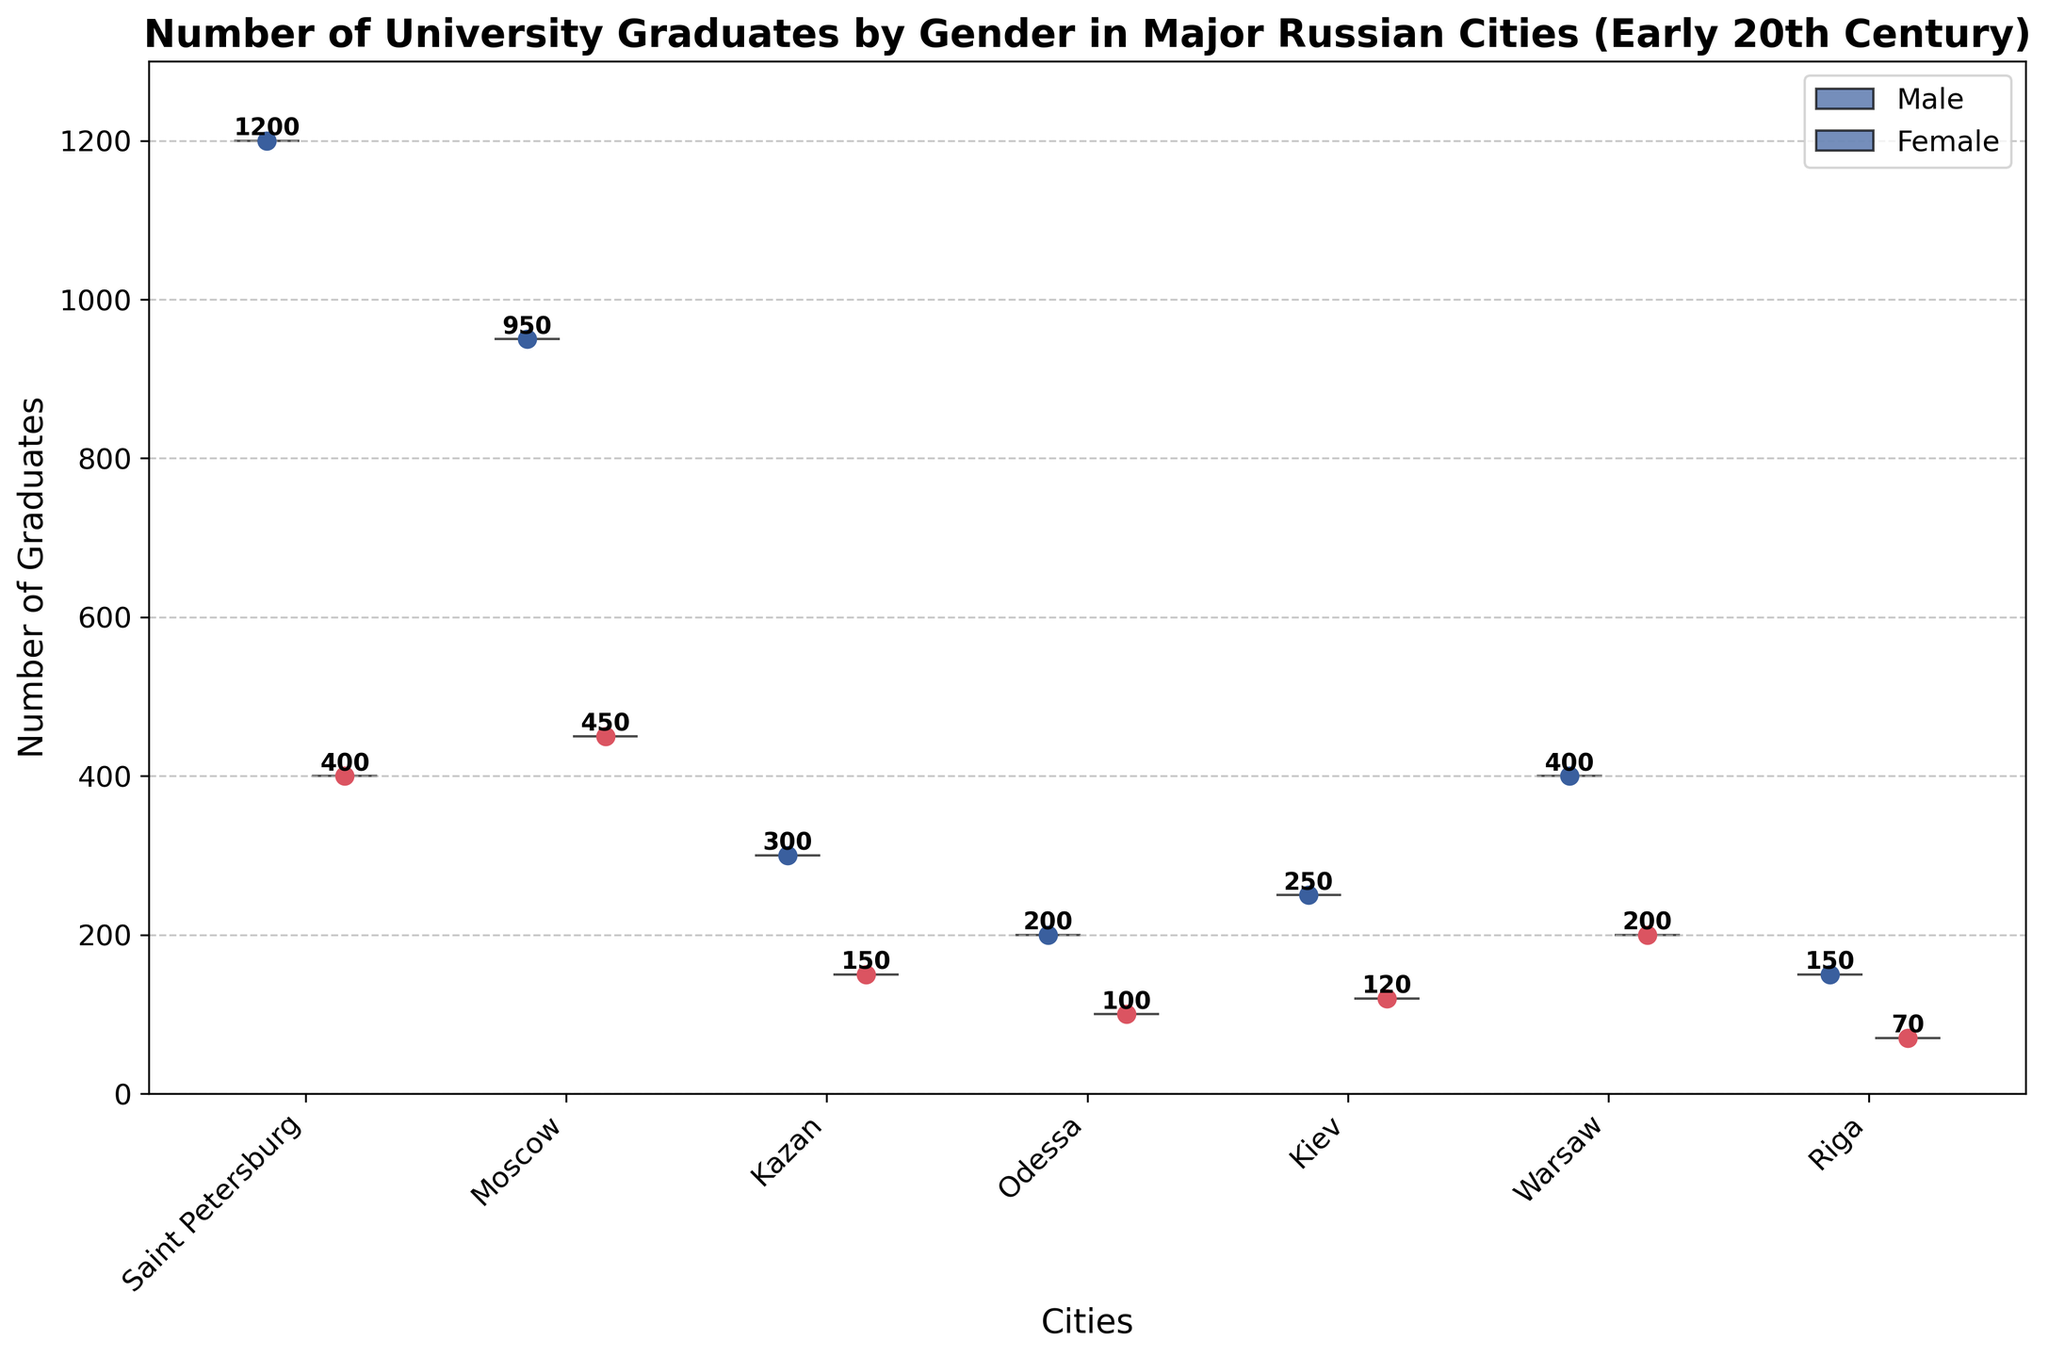What is the title of the chart? The title of the chart is given in text as the description of the overall content it represents. By reading the title, we can understand that the chart is about the number of university graduates by gender in major Russian cities in the early 20th century.
Answer: Number of University Graduates by Gender in Major Russian Cities (Early 20th Century) How many cities are included in the plot? To find the number of cities, you can count the number of distinct labels on the x-axis. Each city is indicated with a two-step interval. By counting, we can see that there are 7 cities labeled.
Answer: 7 Which city has the highest number of male graduates? By looking at the peak points of the violins representing male data which are colored blue, we can see that the highest peak is for Saint Petersburg. The exact number is further annotated as 1200.
Answer: Saint Petersburg What is the difference in the number of graduates between males and females in Moscow? To find the difference, identify the number of graduates for males and females in Moscow. From the annotations, we see that males have 950 graduates and females have 450. The difference is calculated as 950 - 450.
Answer: 500 What color represents female graduates in the plot? By observing the colors used in the chart, we notice that female graduates are represented using a reddish-pink color.
Answer: Reddish-pink Which city has the smallest number of female graduates? We need to check the lowest peak of the violins representing the female data points. The smallest peak among the reddish-pink sections is for Riga, with 70 graduates.
Answer: Riga How many total graduates are there in Kiev? To find this, add the number of male graduates and female graduates in Kiev. The numbers are 250 for males and 120 for females. Adding these gives the total graduates as 250 + 120.
Answer: 370 On average, which city has more females graduating compared to the others? Compare the female graduate numbers annotated for each city. To find averages accurately, sum up the female graduates and divide by the number of cities. However, visually, Saint Petersburg has the highest number annotated at 400, which is consistently higher in value.
Answer: Saint Petersburg Compare the number of graduates between Saint Petersburg and Kazan for both genders. Which city has more graduates in total? Sum the male and female graduates for both cities. Saint Petersburg has 1200 (male) + 400 (female) = 1600 graduates. Kazan has 300 (male) + 150 (female) = 450 graduates. Comparing these sums, Saint Petersburg has more total graduates.
Answer: Saint Petersburg 